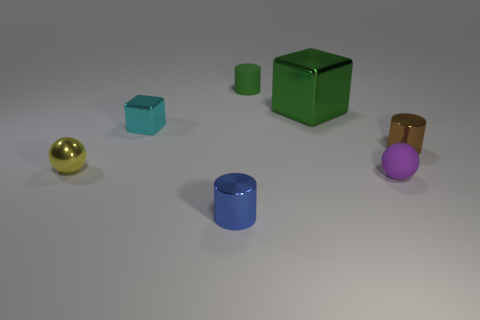Subtract all small shiny cylinders. How many cylinders are left? 1 Subtract all blue cylinders. How many cylinders are left? 2 Add 2 blue matte blocks. How many objects exist? 9 Subtract all balls. How many objects are left? 5 Subtract 1 cubes. How many cubes are left? 1 Subtract all purple cylinders. Subtract all cyan cubes. How many cylinders are left? 3 Subtract all red cylinders. How many yellow blocks are left? 0 Add 6 green metal cubes. How many green metal cubes are left? 7 Add 7 metal blocks. How many metal blocks exist? 9 Subtract 0 gray cubes. How many objects are left? 7 